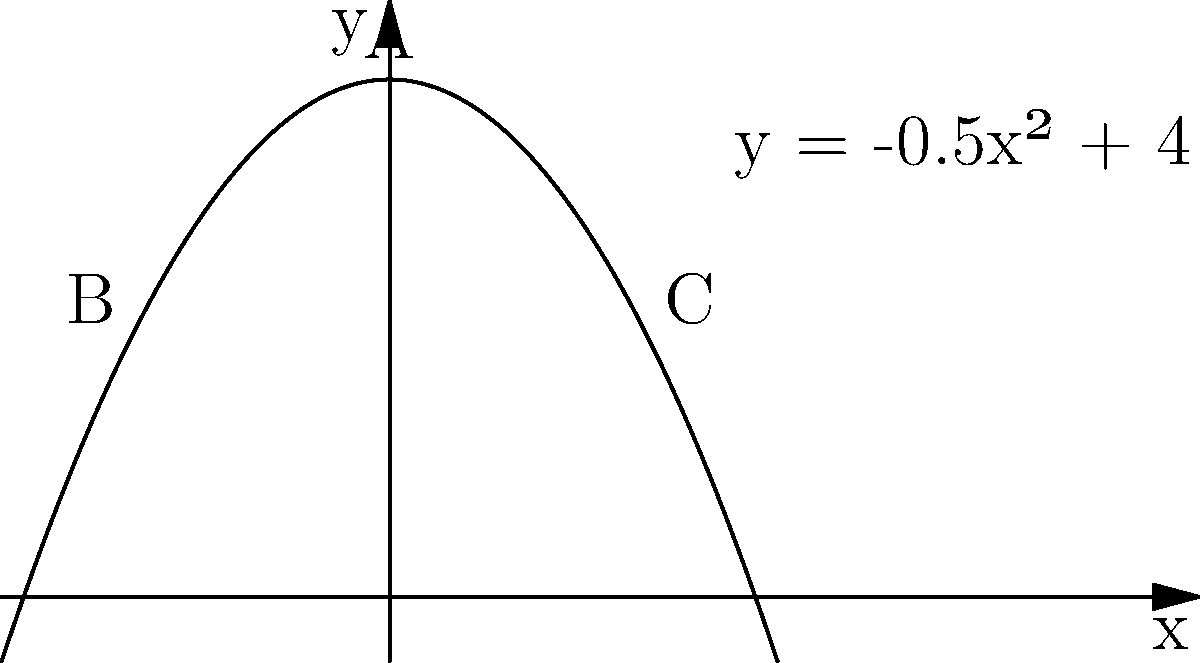A parabola represents the spread of Buddhist teachings in a region, with the y-axis representing the number of followers and the x-axis representing the distance from the origin of the teachings. The parabola is given by the equation $y = -0.5x^2 + 4$. Calculate the area bounded by the parabola and the line $y = 2$ to determine the total reach of the teachings. How does this area relate to the concept of spiritual growth in Buddhism? To solve this problem, we'll follow these steps:

1) First, we need to find the points of intersection between the parabola and the line:
   $-0.5x^2 + 4 = 2$
   $-0.5x^2 = -2$
   $x^2 = 4$
   $x = \pm 2$

   So, the points of intersection are $(-2, 2)$ and $(2, 2)$.

2) The area we're looking for is the area between the parabola and the line $y = 2$ from $x = -2$ to $x = 2$.

3) We can calculate this using the definite integral:

   $$A = \int_{-2}^{2} [(-0.5x^2 + 4) - 2] dx$$

4) Simplifying the integrand:
   $$A = \int_{-2}^{2} [-0.5x^2 + 2] dx$$

5) Integrating:
   $$A = [-\frac{1}{6}x^3 + 2x]_{-2}^{2}$$

6) Evaluating the integral:
   $$A = [-\frac{1}{6}(2^3) + 2(2)] - [-\frac{1}{6}(-2^3) + 2(-2)]$$
   $$A = [-\frac{4}{3} + 4] - [\frac{4}{3} - 4]$$
   $$A = [\frac{8}{3}] - [-\frac{8}{3}]$$
   $$A = \frac{16}{3} \approx 5.33$$

7) In the context of Buddhism, this area could represent the cumulative spiritual growth or enlightenment achieved by followers. The parabolic shape suggests that spiritual growth is most rapid near the source of teachings (x = 0) and slows down as one moves further away, either physically or metaphorically. The bounded area represents the total impact of the teachings within a certain range of influence.
Answer: $\frac{16}{3}$ square units 